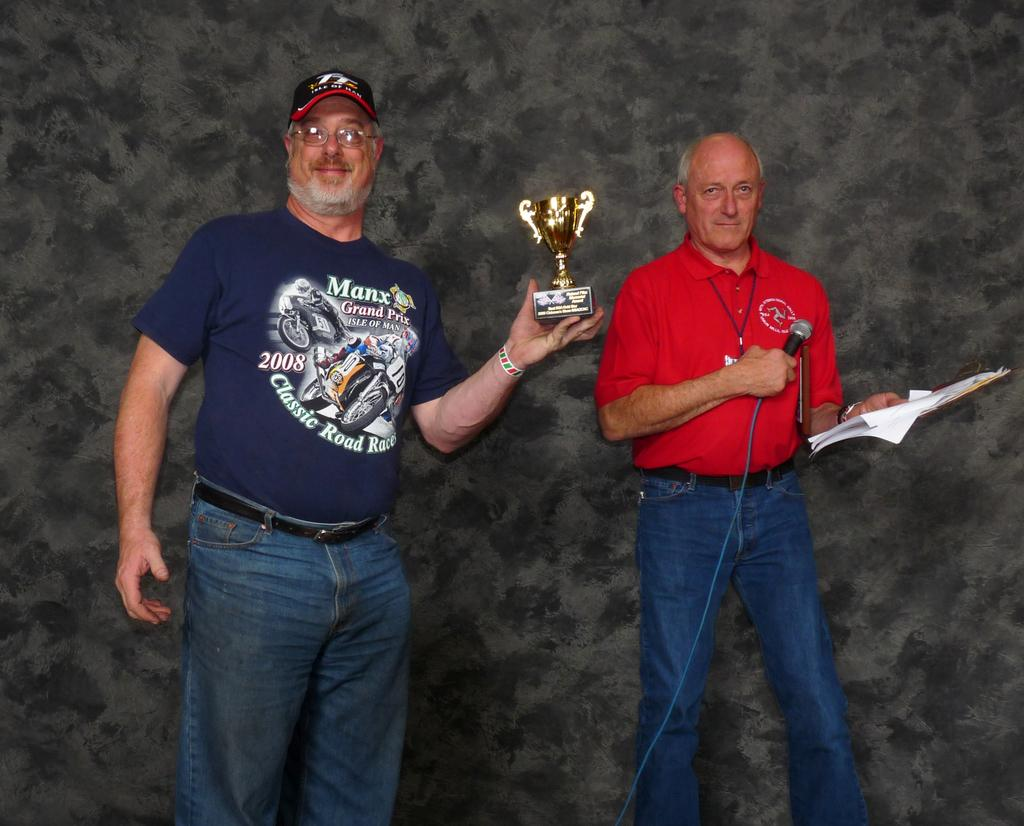What is the person on the left side of the image holding? The person on the left side of the image is holding a trophy. What is the person on the right side of the image holding? The person on the right side of the image is holding a microphone and papers. What might the person with the microphone be doing? The person with the microphone might be making an announcement or giving a speech. How many dogs are present in the image? There are no dogs present in the image. What type of island can be seen in the background of the image? There is no island visible in the image. 